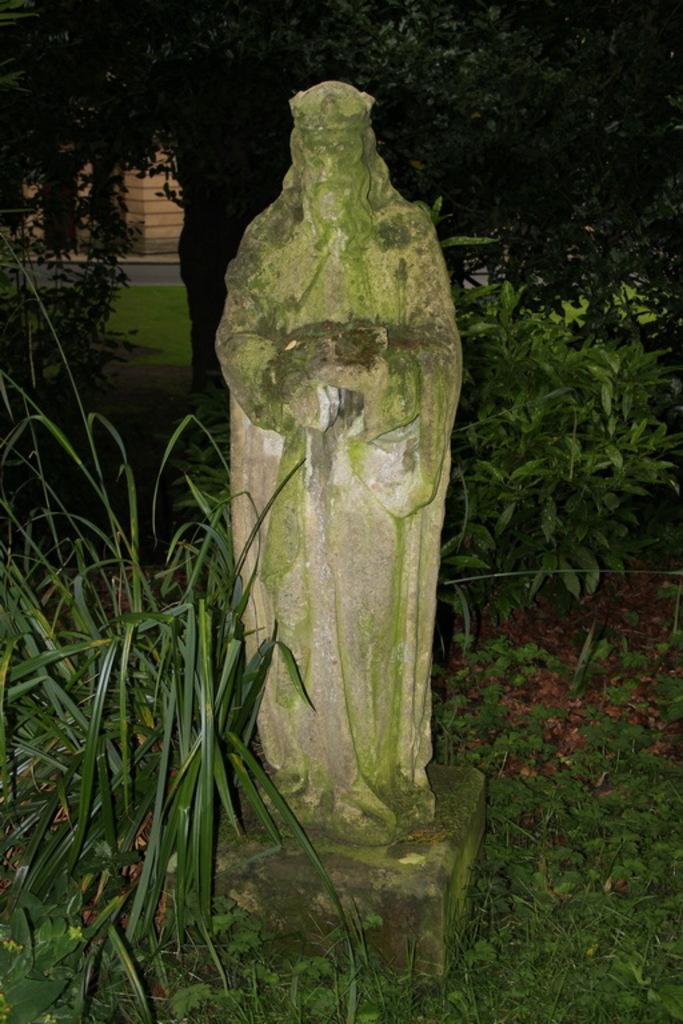Please provide a concise description of this image. In the image there is a sculpture of a person and around that sculpture there is a lot of greenery. 